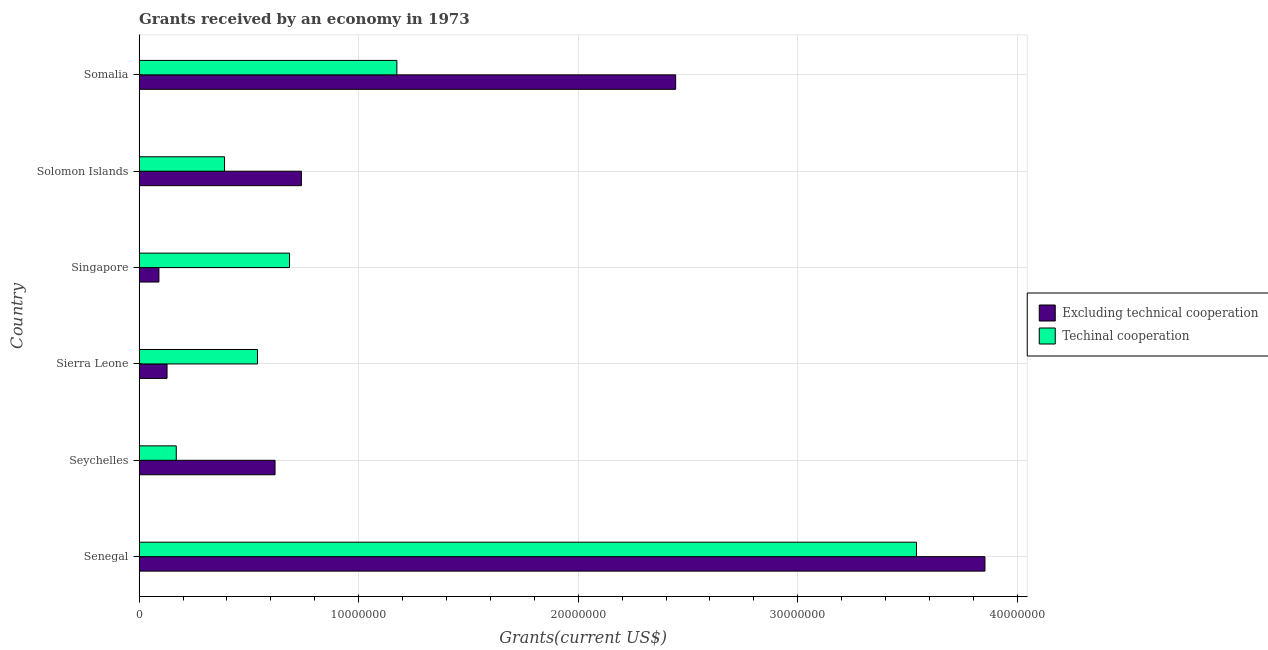How many different coloured bars are there?
Offer a very short reply. 2. Are the number of bars on each tick of the Y-axis equal?
Keep it short and to the point. Yes. How many bars are there on the 1st tick from the top?
Give a very brief answer. 2. How many bars are there on the 5th tick from the bottom?
Your answer should be very brief. 2. What is the label of the 1st group of bars from the top?
Your response must be concise. Somalia. In how many cases, is the number of bars for a given country not equal to the number of legend labels?
Your answer should be very brief. 0. What is the amount of grants received(excluding technical cooperation) in Solomon Islands?
Your answer should be very brief. 7.39e+06. Across all countries, what is the maximum amount of grants received(including technical cooperation)?
Your answer should be very brief. 3.54e+07. Across all countries, what is the minimum amount of grants received(excluding technical cooperation)?
Make the answer very short. 9.00e+05. In which country was the amount of grants received(including technical cooperation) maximum?
Offer a very short reply. Senegal. In which country was the amount of grants received(excluding technical cooperation) minimum?
Your answer should be very brief. Singapore. What is the total amount of grants received(including technical cooperation) in the graph?
Give a very brief answer. 6.50e+07. What is the difference between the amount of grants received(including technical cooperation) in Senegal and that in Sierra Leone?
Give a very brief answer. 3.00e+07. What is the difference between the amount of grants received(excluding technical cooperation) in Solomon Islands and the amount of grants received(including technical cooperation) in Senegal?
Offer a very short reply. -2.80e+07. What is the average amount of grants received(excluding technical cooperation) per country?
Provide a succinct answer. 1.31e+07. What is the difference between the amount of grants received(excluding technical cooperation) and amount of grants received(including technical cooperation) in Seychelles?
Keep it short and to the point. 4.50e+06. In how many countries, is the amount of grants received(excluding technical cooperation) greater than 10000000 US$?
Keep it short and to the point. 2. What is the ratio of the amount of grants received(including technical cooperation) in Senegal to that in Somalia?
Give a very brief answer. 3.02. Is the difference between the amount of grants received(including technical cooperation) in Singapore and Somalia greater than the difference between the amount of grants received(excluding technical cooperation) in Singapore and Somalia?
Your answer should be very brief. Yes. What is the difference between the highest and the second highest amount of grants received(including technical cooperation)?
Your answer should be compact. 2.37e+07. What is the difference between the highest and the lowest amount of grants received(excluding technical cooperation)?
Your answer should be very brief. 3.76e+07. In how many countries, is the amount of grants received(including technical cooperation) greater than the average amount of grants received(including technical cooperation) taken over all countries?
Provide a succinct answer. 2. Is the sum of the amount of grants received(including technical cooperation) in Sierra Leone and Solomon Islands greater than the maximum amount of grants received(excluding technical cooperation) across all countries?
Offer a very short reply. No. What does the 2nd bar from the top in Senegal represents?
Your answer should be compact. Excluding technical cooperation. What does the 1st bar from the bottom in Singapore represents?
Give a very brief answer. Excluding technical cooperation. How many countries are there in the graph?
Give a very brief answer. 6. What is the difference between two consecutive major ticks on the X-axis?
Offer a very short reply. 1.00e+07. Does the graph contain any zero values?
Offer a terse response. No. Does the graph contain grids?
Keep it short and to the point. Yes. Where does the legend appear in the graph?
Your answer should be very brief. Center right. What is the title of the graph?
Your answer should be very brief. Grants received by an economy in 1973. What is the label or title of the X-axis?
Give a very brief answer. Grants(current US$). What is the label or title of the Y-axis?
Ensure brevity in your answer.  Country. What is the Grants(current US$) of Excluding technical cooperation in Senegal?
Give a very brief answer. 3.85e+07. What is the Grants(current US$) of Techinal cooperation in Senegal?
Your response must be concise. 3.54e+07. What is the Grants(current US$) in Excluding technical cooperation in Seychelles?
Offer a very short reply. 6.19e+06. What is the Grants(current US$) of Techinal cooperation in Seychelles?
Provide a short and direct response. 1.69e+06. What is the Grants(current US$) in Excluding technical cooperation in Sierra Leone?
Provide a succinct answer. 1.27e+06. What is the Grants(current US$) of Techinal cooperation in Sierra Leone?
Offer a terse response. 5.39e+06. What is the Grants(current US$) in Excluding technical cooperation in Singapore?
Ensure brevity in your answer.  9.00e+05. What is the Grants(current US$) of Techinal cooperation in Singapore?
Your response must be concise. 6.85e+06. What is the Grants(current US$) in Excluding technical cooperation in Solomon Islands?
Provide a short and direct response. 7.39e+06. What is the Grants(current US$) of Techinal cooperation in Solomon Islands?
Your answer should be very brief. 3.89e+06. What is the Grants(current US$) in Excluding technical cooperation in Somalia?
Ensure brevity in your answer.  2.44e+07. What is the Grants(current US$) in Techinal cooperation in Somalia?
Your answer should be compact. 1.17e+07. Across all countries, what is the maximum Grants(current US$) in Excluding technical cooperation?
Offer a very short reply. 3.85e+07. Across all countries, what is the maximum Grants(current US$) of Techinal cooperation?
Keep it short and to the point. 3.54e+07. Across all countries, what is the minimum Grants(current US$) in Techinal cooperation?
Offer a very short reply. 1.69e+06. What is the total Grants(current US$) of Excluding technical cooperation in the graph?
Give a very brief answer. 7.87e+07. What is the total Grants(current US$) of Techinal cooperation in the graph?
Ensure brevity in your answer.  6.50e+07. What is the difference between the Grants(current US$) of Excluding technical cooperation in Senegal and that in Seychelles?
Ensure brevity in your answer.  3.23e+07. What is the difference between the Grants(current US$) in Techinal cooperation in Senegal and that in Seychelles?
Offer a very short reply. 3.37e+07. What is the difference between the Grants(current US$) of Excluding technical cooperation in Senegal and that in Sierra Leone?
Offer a very short reply. 3.73e+07. What is the difference between the Grants(current US$) of Techinal cooperation in Senegal and that in Sierra Leone?
Make the answer very short. 3.00e+07. What is the difference between the Grants(current US$) in Excluding technical cooperation in Senegal and that in Singapore?
Your response must be concise. 3.76e+07. What is the difference between the Grants(current US$) of Techinal cooperation in Senegal and that in Singapore?
Make the answer very short. 2.86e+07. What is the difference between the Grants(current US$) of Excluding technical cooperation in Senegal and that in Solomon Islands?
Offer a very short reply. 3.11e+07. What is the difference between the Grants(current US$) of Techinal cooperation in Senegal and that in Solomon Islands?
Give a very brief answer. 3.15e+07. What is the difference between the Grants(current US$) of Excluding technical cooperation in Senegal and that in Somalia?
Provide a succinct answer. 1.41e+07. What is the difference between the Grants(current US$) of Techinal cooperation in Senegal and that in Somalia?
Ensure brevity in your answer.  2.37e+07. What is the difference between the Grants(current US$) of Excluding technical cooperation in Seychelles and that in Sierra Leone?
Offer a terse response. 4.92e+06. What is the difference between the Grants(current US$) in Techinal cooperation in Seychelles and that in Sierra Leone?
Keep it short and to the point. -3.70e+06. What is the difference between the Grants(current US$) in Excluding technical cooperation in Seychelles and that in Singapore?
Offer a very short reply. 5.29e+06. What is the difference between the Grants(current US$) in Techinal cooperation in Seychelles and that in Singapore?
Your response must be concise. -5.16e+06. What is the difference between the Grants(current US$) of Excluding technical cooperation in Seychelles and that in Solomon Islands?
Give a very brief answer. -1.20e+06. What is the difference between the Grants(current US$) in Techinal cooperation in Seychelles and that in Solomon Islands?
Your answer should be compact. -2.20e+06. What is the difference between the Grants(current US$) of Excluding technical cooperation in Seychelles and that in Somalia?
Give a very brief answer. -1.82e+07. What is the difference between the Grants(current US$) in Techinal cooperation in Seychelles and that in Somalia?
Make the answer very short. -1.00e+07. What is the difference between the Grants(current US$) in Techinal cooperation in Sierra Leone and that in Singapore?
Your answer should be compact. -1.46e+06. What is the difference between the Grants(current US$) in Excluding technical cooperation in Sierra Leone and that in Solomon Islands?
Your response must be concise. -6.12e+06. What is the difference between the Grants(current US$) in Techinal cooperation in Sierra Leone and that in Solomon Islands?
Ensure brevity in your answer.  1.50e+06. What is the difference between the Grants(current US$) in Excluding technical cooperation in Sierra Leone and that in Somalia?
Your answer should be compact. -2.32e+07. What is the difference between the Grants(current US$) in Techinal cooperation in Sierra Leone and that in Somalia?
Your response must be concise. -6.35e+06. What is the difference between the Grants(current US$) of Excluding technical cooperation in Singapore and that in Solomon Islands?
Your answer should be compact. -6.49e+06. What is the difference between the Grants(current US$) of Techinal cooperation in Singapore and that in Solomon Islands?
Keep it short and to the point. 2.96e+06. What is the difference between the Grants(current US$) of Excluding technical cooperation in Singapore and that in Somalia?
Ensure brevity in your answer.  -2.35e+07. What is the difference between the Grants(current US$) in Techinal cooperation in Singapore and that in Somalia?
Offer a very short reply. -4.89e+06. What is the difference between the Grants(current US$) in Excluding technical cooperation in Solomon Islands and that in Somalia?
Make the answer very short. -1.70e+07. What is the difference between the Grants(current US$) of Techinal cooperation in Solomon Islands and that in Somalia?
Ensure brevity in your answer.  -7.85e+06. What is the difference between the Grants(current US$) in Excluding technical cooperation in Senegal and the Grants(current US$) in Techinal cooperation in Seychelles?
Your answer should be very brief. 3.68e+07. What is the difference between the Grants(current US$) in Excluding technical cooperation in Senegal and the Grants(current US$) in Techinal cooperation in Sierra Leone?
Keep it short and to the point. 3.31e+07. What is the difference between the Grants(current US$) in Excluding technical cooperation in Senegal and the Grants(current US$) in Techinal cooperation in Singapore?
Your answer should be very brief. 3.17e+07. What is the difference between the Grants(current US$) in Excluding technical cooperation in Senegal and the Grants(current US$) in Techinal cooperation in Solomon Islands?
Ensure brevity in your answer.  3.46e+07. What is the difference between the Grants(current US$) of Excluding technical cooperation in Senegal and the Grants(current US$) of Techinal cooperation in Somalia?
Make the answer very short. 2.68e+07. What is the difference between the Grants(current US$) in Excluding technical cooperation in Seychelles and the Grants(current US$) in Techinal cooperation in Sierra Leone?
Your response must be concise. 8.00e+05. What is the difference between the Grants(current US$) in Excluding technical cooperation in Seychelles and the Grants(current US$) in Techinal cooperation in Singapore?
Make the answer very short. -6.60e+05. What is the difference between the Grants(current US$) of Excluding technical cooperation in Seychelles and the Grants(current US$) of Techinal cooperation in Solomon Islands?
Your answer should be very brief. 2.30e+06. What is the difference between the Grants(current US$) in Excluding technical cooperation in Seychelles and the Grants(current US$) in Techinal cooperation in Somalia?
Your answer should be compact. -5.55e+06. What is the difference between the Grants(current US$) of Excluding technical cooperation in Sierra Leone and the Grants(current US$) of Techinal cooperation in Singapore?
Offer a terse response. -5.58e+06. What is the difference between the Grants(current US$) of Excluding technical cooperation in Sierra Leone and the Grants(current US$) of Techinal cooperation in Solomon Islands?
Offer a terse response. -2.62e+06. What is the difference between the Grants(current US$) of Excluding technical cooperation in Sierra Leone and the Grants(current US$) of Techinal cooperation in Somalia?
Offer a very short reply. -1.05e+07. What is the difference between the Grants(current US$) in Excluding technical cooperation in Singapore and the Grants(current US$) in Techinal cooperation in Solomon Islands?
Offer a terse response. -2.99e+06. What is the difference between the Grants(current US$) in Excluding technical cooperation in Singapore and the Grants(current US$) in Techinal cooperation in Somalia?
Make the answer very short. -1.08e+07. What is the difference between the Grants(current US$) of Excluding technical cooperation in Solomon Islands and the Grants(current US$) of Techinal cooperation in Somalia?
Ensure brevity in your answer.  -4.35e+06. What is the average Grants(current US$) of Excluding technical cooperation per country?
Offer a terse response. 1.31e+07. What is the average Grants(current US$) in Techinal cooperation per country?
Make the answer very short. 1.08e+07. What is the difference between the Grants(current US$) in Excluding technical cooperation and Grants(current US$) in Techinal cooperation in Senegal?
Your response must be concise. 3.12e+06. What is the difference between the Grants(current US$) of Excluding technical cooperation and Grants(current US$) of Techinal cooperation in Seychelles?
Ensure brevity in your answer.  4.50e+06. What is the difference between the Grants(current US$) in Excluding technical cooperation and Grants(current US$) in Techinal cooperation in Sierra Leone?
Your answer should be compact. -4.12e+06. What is the difference between the Grants(current US$) of Excluding technical cooperation and Grants(current US$) of Techinal cooperation in Singapore?
Provide a succinct answer. -5.95e+06. What is the difference between the Grants(current US$) of Excluding technical cooperation and Grants(current US$) of Techinal cooperation in Solomon Islands?
Keep it short and to the point. 3.50e+06. What is the difference between the Grants(current US$) of Excluding technical cooperation and Grants(current US$) of Techinal cooperation in Somalia?
Make the answer very short. 1.27e+07. What is the ratio of the Grants(current US$) in Excluding technical cooperation in Senegal to that in Seychelles?
Keep it short and to the point. 6.22. What is the ratio of the Grants(current US$) of Techinal cooperation in Senegal to that in Seychelles?
Offer a very short reply. 20.95. What is the ratio of the Grants(current US$) in Excluding technical cooperation in Senegal to that in Sierra Leone?
Your response must be concise. 30.34. What is the ratio of the Grants(current US$) in Techinal cooperation in Senegal to that in Sierra Leone?
Give a very brief answer. 6.57. What is the ratio of the Grants(current US$) of Excluding technical cooperation in Senegal to that in Singapore?
Your answer should be compact. 42.81. What is the ratio of the Grants(current US$) in Techinal cooperation in Senegal to that in Singapore?
Provide a short and direct response. 5.17. What is the ratio of the Grants(current US$) in Excluding technical cooperation in Senegal to that in Solomon Islands?
Offer a terse response. 5.21. What is the ratio of the Grants(current US$) in Techinal cooperation in Senegal to that in Solomon Islands?
Your response must be concise. 9.1. What is the ratio of the Grants(current US$) of Excluding technical cooperation in Senegal to that in Somalia?
Provide a succinct answer. 1.58. What is the ratio of the Grants(current US$) of Techinal cooperation in Senegal to that in Somalia?
Keep it short and to the point. 3.02. What is the ratio of the Grants(current US$) in Excluding technical cooperation in Seychelles to that in Sierra Leone?
Offer a terse response. 4.87. What is the ratio of the Grants(current US$) of Techinal cooperation in Seychelles to that in Sierra Leone?
Provide a short and direct response. 0.31. What is the ratio of the Grants(current US$) in Excluding technical cooperation in Seychelles to that in Singapore?
Your answer should be compact. 6.88. What is the ratio of the Grants(current US$) in Techinal cooperation in Seychelles to that in Singapore?
Offer a very short reply. 0.25. What is the ratio of the Grants(current US$) of Excluding technical cooperation in Seychelles to that in Solomon Islands?
Provide a succinct answer. 0.84. What is the ratio of the Grants(current US$) in Techinal cooperation in Seychelles to that in Solomon Islands?
Your answer should be compact. 0.43. What is the ratio of the Grants(current US$) of Excluding technical cooperation in Seychelles to that in Somalia?
Provide a short and direct response. 0.25. What is the ratio of the Grants(current US$) in Techinal cooperation in Seychelles to that in Somalia?
Offer a terse response. 0.14. What is the ratio of the Grants(current US$) of Excluding technical cooperation in Sierra Leone to that in Singapore?
Provide a short and direct response. 1.41. What is the ratio of the Grants(current US$) in Techinal cooperation in Sierra Leone to that in Singapore?
Your response must be concise. 0.79. What is the ratio of the Grants(current US$) in Excluding technical cooperation in Sierra Leone to that in Solomon Islands?
Make the answer very short. 0.17. What is the ratio of the Grants(current US$) of Techinal cooperation in Sierra Leone to that in Solomon Islands?
Ensure brevity in your answer.  1.39. What is the ratio of the Grants(current US$) in Excluding technical cooperation in Sierra Leone to that in Somalia?
Provide a succinct answer. 0.05. What is the ratio of the Grants(current US$) in Techinal cooperation in Sierra Leone to that in Somalia?
Give a very brief answer. 0.46. What is the ratio of the Grants(current US$) in Excluding technical cooperation in Singapore to that in Solomon Islands?
Your answer should be very brief. 0.12. What is the ratio of the Grants(current US$) in Techinal cooperation in Singapore to that in Solomon Islands?
Offer a very short reply. 1.76. What is the ratio of the Grants(current US$) of Excluding technical cooperation in Singapore to that in Somalia?
Provide a short and direct response. 0.04. What is the ratio of the Grants(current US$) of Techinal cooperation in Singapore to that in Somalia?
Your answer should be very brief. 0.58. What is the ratio of the Grants(current US$) in Excluding technical cooperation in Solomon Islands to that in Somalia?
Your response must be concise. 0.3. What is the ratio of the Grants(current US$) of Techinal cooperation in Solomon Islands to that in Somalia?
Ensure brevity in your answer.  0.33. What is the difference between the highest and the second highest Grants(current US$) in Excluding technical cooperation?
Make the answer very short. 1.41e+07. What is the difference between the highest and the second highest Grants(current US$) in Techinal cooperation?
Provide a succinct answer. 2.37e+07. What is the difference between the highest and the lowest Grants(current US$) of Excluding technical cooperation?
Offer a terse response. 3.76e+07. What is the difference between the highest and the lowest Grants(current US$) in Techinal cooperation?
Offer a terse response. 3.37e+07. 